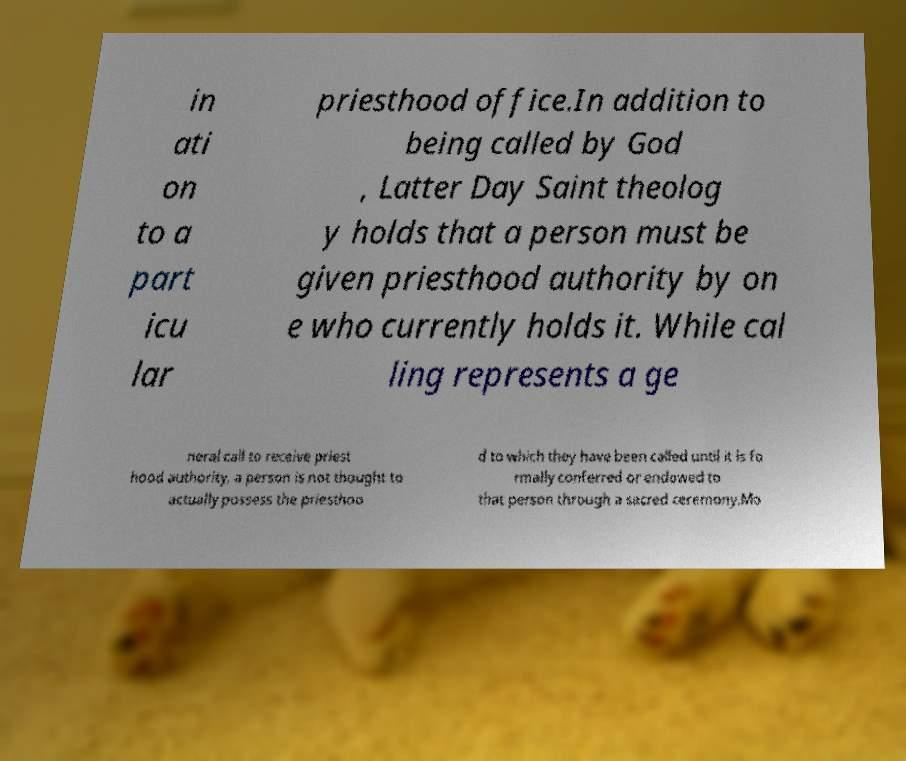Can you read and provide the text displayed in the image?This photo seems to have some interesting text. Can you extract and type it out for me? in ati on to a part icu lar priesthood office.In addition to being called by God , Latter Day Saint theolog y holds that a person must be given priesthood authority by on e who currently holds it. While cal ling represents a ge neral call to receive priest hood authority, a person is not thought to actually possess the priesthoo d to which they have been called until it is fo rmally conferred or endowed to that person through a sacred ceremony.Mo 